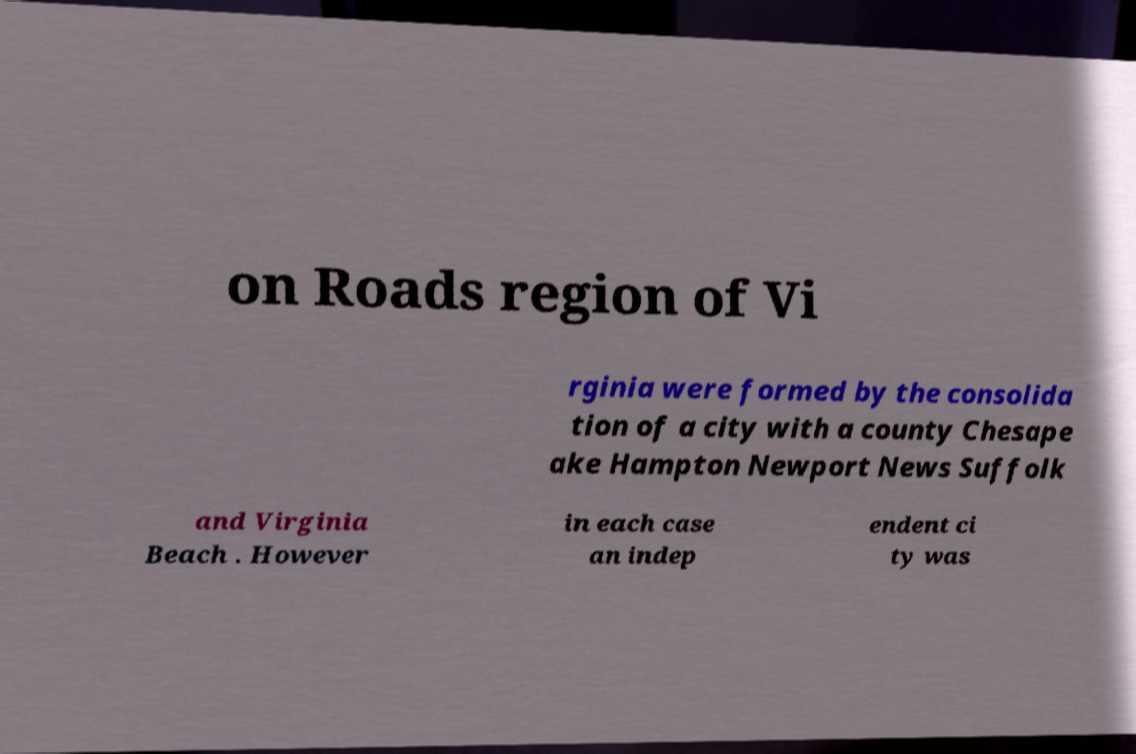Can you read and provide the text displayed in the image?This photo seems to have some interesting text. Can you extract and type it out for me? on Roads region of Vi rginia were formed by the consolida tion of a city with a county Chesape ake Hampton Newport News Suffolk and Virginia Beach . However in each case an indep endent ci ty was 